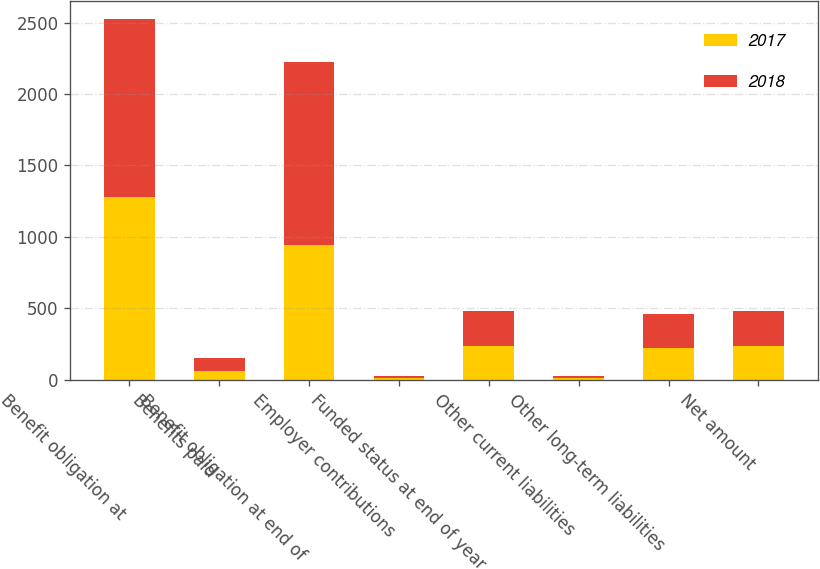<chart> <loc_0><loc_0><loc_500><loc_500><stacked_bar_chart><ecel><fcel>Benefit obligation at<fcel>Benefits paid<fcel>Benefit obligation at end of<fcel>Employer contributions<fcel>Funded status at end of year<fcel>Other current liabilities<fcel>Other long-term liabilities<fcel>Net amount<nl><fcel>2017<fcel>1279<fcel>60<fcel>943<fcel>14<fcel>234<fcel>14<fcel>223<fcel>234<nl><fcel>2018<fcel>1249<fcel>88<fcel>1279<fcel>14<fcel>244<fcel>13<fcel>235<fcel>244<nl></chart> 